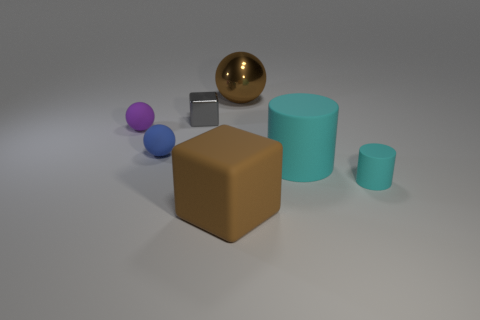Do the gray thing and the tiny thing that is on the right side of the brown block have the same material?
Provide a short and direct response. No. What color is the object that is in front of the purple matte ball and to the left of the large brown rubber object?
Provide a succinct answer. Blue. What number of cylinders are large brown things or cyan rubber things?
Your answer should be compact. 2. There is a tiny blue object; does it have the same shape as the large thing that is behind the blue ball?
Your answer should be compact. Yes. There is a thing that is in front of the metallic ball and behind the purple rubber ball; what size is it?
Provide a succinct answer. Small. The tiny cyan thing is what shape?
Make the answer very short. Cylinder. Are there any small balls that are behind the tiny thing on the left side of the blue object?
Offer a terse response. No. There is a cube right of the tiny gray thing; how many small objects are on the left side of it?
Keep it short and to the point. 3. What is the material of the cyan cylinder that is the same size as the gray shiny cube?
Offer a terse response. Rubber. There is a big brown object that is in front of the tiny cyan thing; is it the same shape as the big brown metal thing?
Give a very brief answer. No. 